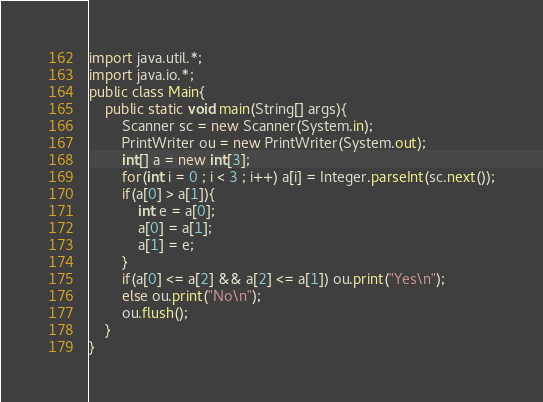Convert code to text. <code><loc_0><loc_0><loc_500><loc_500><_Java_>import java.util.*;
import java.io.*;
public class Main{
    public static void main(String[] args){
		Scanner sc = new Scanner(System.in);
		PrintWriter ou = new PrintWriter(System.out);
		int[] a = new int[3];
		for(int i = 0 ; i < 3 ; i++) a[i] = Integer.parseInt(sc.next());
		if(a[0] > a[1]){
			int e = a[0];
			a[0] = a[1];
			a[1] = e;
		}
		if(a[0] <= a[2] && a[2] <= a[1]) ou.print("Yes\n");
		else ou.print("No\n");
		ou.flush();
    }
}</code> 